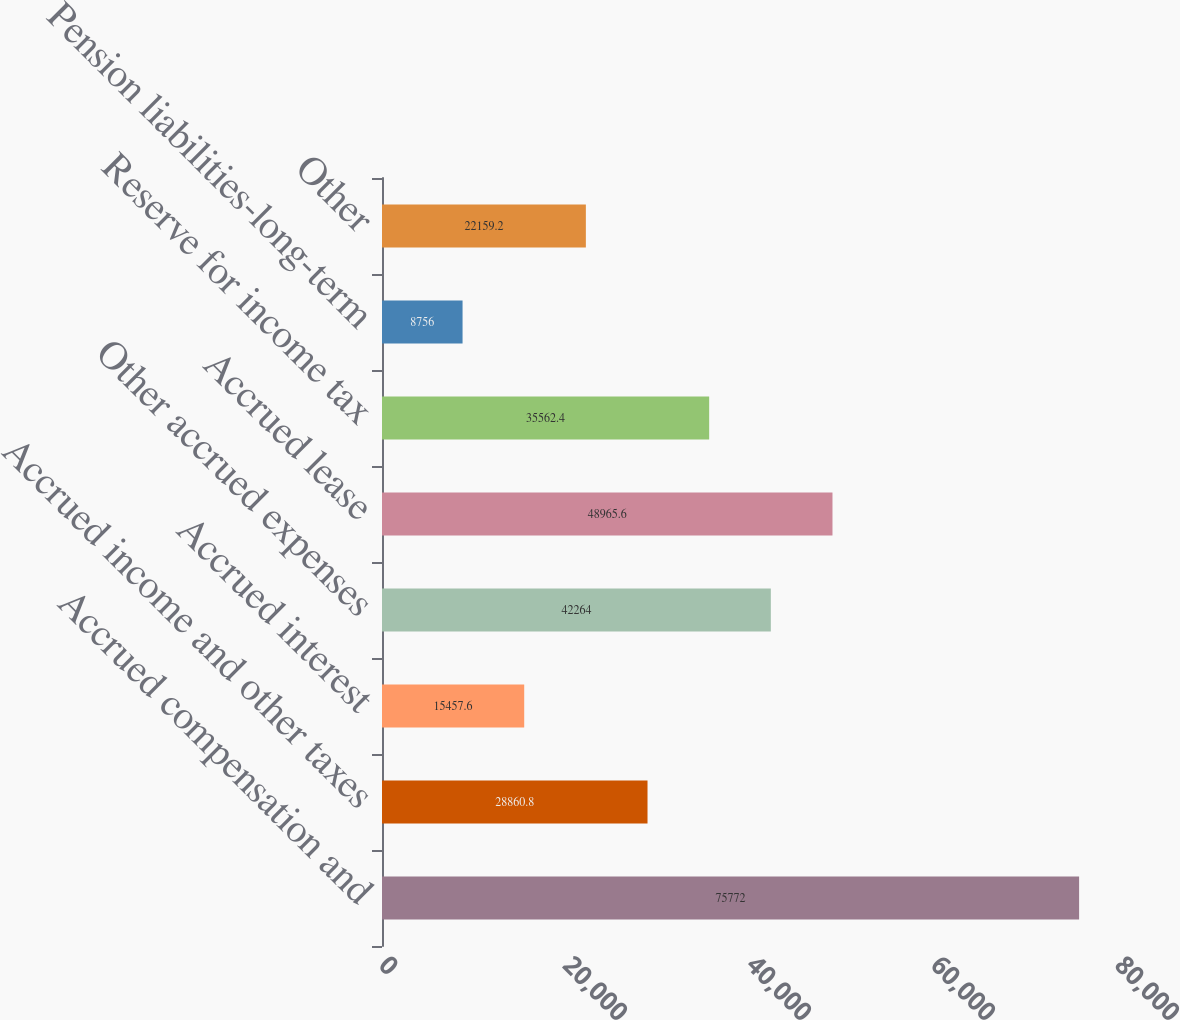Convert chart to OTSL. <chart><loc_0><loc_0><loc_500><loc_500><bar_chart><fcel>Accrued compensation and<fcel>Accrued income and other taxes<fcel>Accrued interest<fcel>Other accrued expenses<fcel>Accrued lease<fcel>Reserve for income tax<fcel>Pension liabilities-long-term<fcel>Other<nl><fcel>75772<fcel>28860.8<fcel>15457.6<fcel>42264<fcel>48965.6<fcel>35562.4<fcel>8756<fcel>22159.2<nl></chart> 